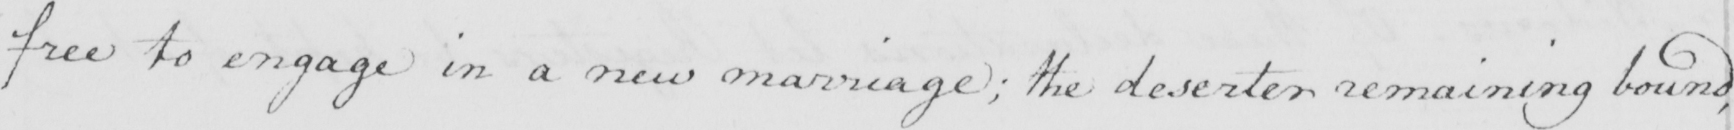What is written in this line of handwriting? free to engage in a new marriage ; the deserter remaining bound , 